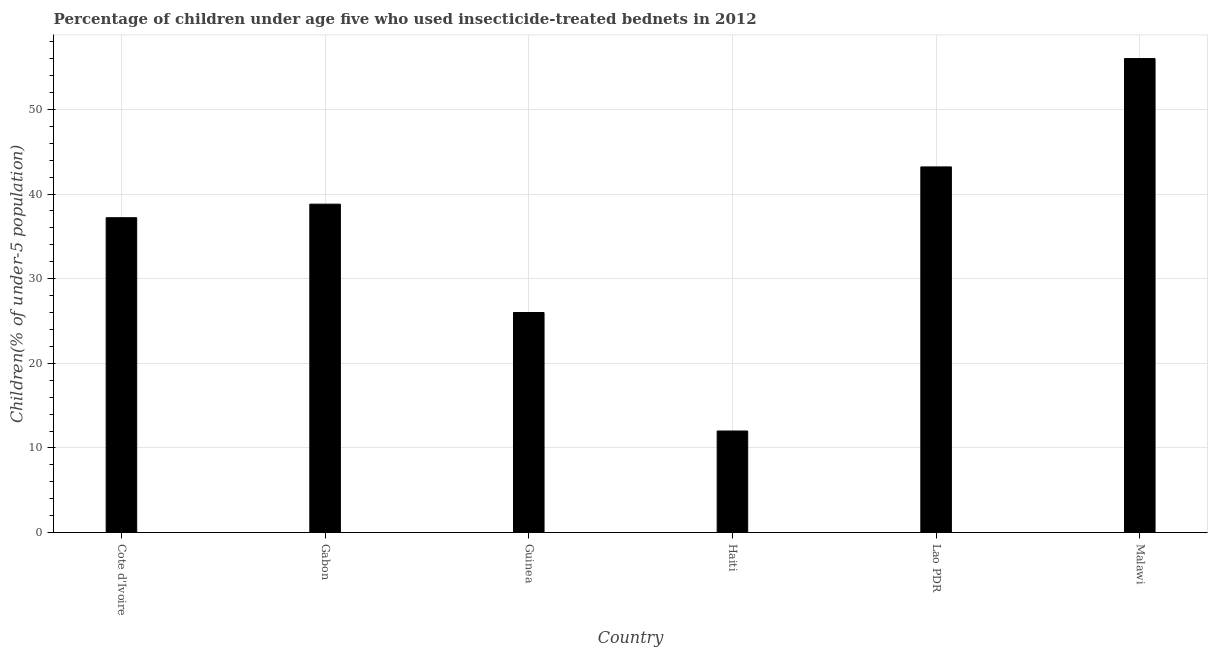Does the graph contain any zero values?
Provide a short and direct response. No. Does the graph contain grids?
Provide a short and direct response. Yes. What is the title of the graph?
Offer a very short reply. Percentage of children under age five who used insecticide-treated bednets in 2012. What is the label or title of the X-axis?
Ensure brevity in your answer.  Country. What is the label or title of the Y-axis?
Offer a very short reply. Children(% of under-5 population). What is the percentage of children who use of insecticide-treated bed nets in Gabon?
Offer a terse response. 38.8. Across all countries, what is the maximum percentage of children who use of insecticide-treated bed nets?
Give a very brief answer. 56. Across all countries, what is the minimum percentage of children who use of insecticide-treated bed nets?
Your response must be concise. 12. In which country was the percentage of children who use of insecticide-treated bed nets maximum?
Your answer should be very brief. Malawi. In which country was the percentage of children who use of insecticide-treated bed nets minimum?
Your response must be concise. Haiti. What is the sum of the percentage of children who use of insecticide-treated bed nets?
Keep it short and to the point. 213.2. What is the difference between the percentage of children who use of insecticide-treated bed nets in Cote d'Ivoire and Haiti?
Make the answer very short. 25.2. What is the average percentage of children who use of insecticide-treated bed nets per country?
Ensure brevity in your answer.  35.53. What is the median percentage of children who use of insecticide-treated bed nets?
Give a very brief answer. 38. In how many countries, is the percentage of children who use of insecticide-treated bed nets greater than 10 %?
Give a very brief answer. 6. Is the percentage of children who use of insecticide-treated bed nets in Cote d'Ivoire less than that in Guinea?
Give a very brief answer. No. Is the difference between the percentage of children who use of insecticide-treated bed nets in Cote d'Ivoire and Malawi greater than the difference between any two countries?
Keep it short and to the point. No. What is the difference between the highest and the second highest percentage of children who use of insecticide-treated bed nets?
Your answer should be compact. 12.8. Is the sum of the percentage of children who use of insecticide-treated bed nets in Guinea and Haiti greater than the maximum percentage of children who use of insecticide-treated bed nets across all countries?
Ensure brevity in your answer.  No. What is the difference between the highest and the lowest percentage of children who use of insecticide-treated bed nets?
Your answer should be very brief. 44. In how many countries, is the percentage of children who use of insecticide-treated bed nets greater than the average percentage of children who use of insecticide-treated bed nets taken over all countries?
Provide a succinct answer. 4. What is the Children(% of under-5 population) of Cote d'Ivoire?
Your response must be concise. 37.2. What is the Children(% of under-5 population) of Gabon?
Offer a terse response. 38.8. What is the Children(% of under-5 population) in Lao PDR?
Your answer should be compact. 43.2. What is the difference between the Children(% of under-5 population) in Cote d'Ivoire and Gabon?
Keep it short and to the point. -1.6. What is the difference between the Children(% of under-5 population) in Cote d'Ivoire and Haiti?
Provide a succinct answer. 25.2. What is the difference between the Children(% of under-5 population) in Cote d'Ivoire and Lao PDR?
Keep it short and to the point. -6. What is the difference between the Children(% of under-5 population) in Cote d'Ivoire and Malawi?
Give a very brief answer. -18.8. What is the difference between the Children(% of under-5 population) in Gabon and Haiti?
Your answer should be very brief. 26.8. What is the difference between the Children(% of under-5 population) in Gabon and Malawi?
Offer a terse response. -17.2. What is the difference between the Children(% of under-5 population) in Guinea and Haiti?
Provide a short and direct response. 14. What is the difference between the Children(% of under-5 population) in Guinea and Lao PDR?
Your answer should be compact. -17.2. What is the difference between the Children(% of under-5 population) in Guinea and Malawi?
Your response must be concise. -30. What is the difference between the Children(% of under-5 population) in Haiti and Lao PDR?
Offer a terse response. -31.2. What is the difference between the Children(% of under-5 population) in Haiti and Malawi?
Your response must be concise. -44. What is the ratio of the Children(% of under-5 population) in Cote d'Ivoire to that in Guinea?
Keep it short and to the point. 1.43. What is the ratio of the Children(% of under-5 population) in Cote d'Ivoire to that in Lao PDR?
Give a very brief answer. 0.86. What is the ratio of the Children(% of under-5 population) in Cote d'Ivoire to that in Malawi?
Offer a terse response. 0.66. What is the ratio of the Children(% of under-5 population) in Gabon to that in Guinea?
Ensure brevity in your answer.  1.49. What is the ratio of the Children(% of under-5 population) in Gabon to that in Haiti?
Make the answer very short. 3.23. What is the ratio of the Children(% of under-5 population) in Gabon to that in Lao PDR?
Provide a succinct answer. 0.9. What is the ratio of the Children(% of under-5 population) in Gabon to that in Malawi?
Provide a succinct answer. 0.69. What is the ratio of the Children(% of under-5 population) in Guinea to that in Haiti?
Your answer should be very brief. 2.17. What is the ratio of the Children(% of under-5 population) in Guinea to that in Lao PDR?
Give a very brief answer. 0.6. What is the ratio of the Children(% of under-5 population) in Guinea to that in Malawi?
Offer a very short reply. 0.46. What is the ratio of the Children(% of under-5 population) in Haiti to that in Lao PDR?
Your answer should be compact. 0.28. What is the ratio of the Children(% of under-5 population) in Haiti to that in Malawi?
Your answer should be compact. 0.21. What is the ratio of the Children(% of under-5 population) in Lao PDR to that in Malawi?
Provide a succinct answer. 0.77. 